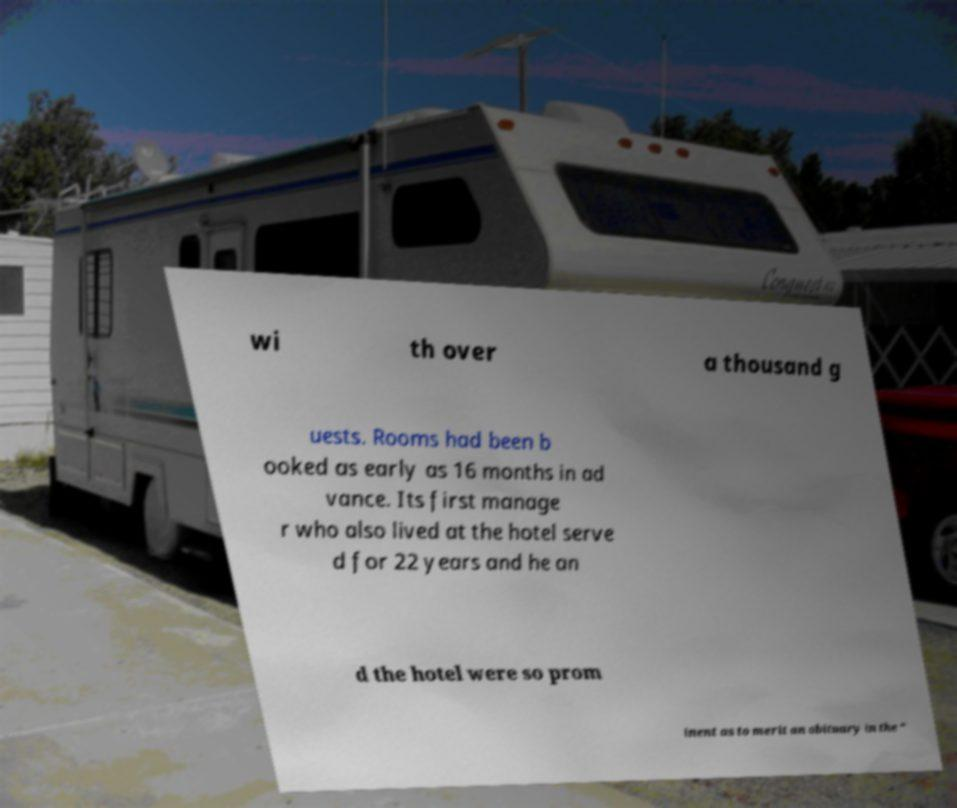Please read and relay the text visible in this image. What does it say? wi th over a thousand g uests. Rooms had been b ooked as early as 16 months in ad vance. Its first manage r who also lived at the hotel serve d for 22 years and he an d the hotel were so prom inent as to merit an obituary in the " 